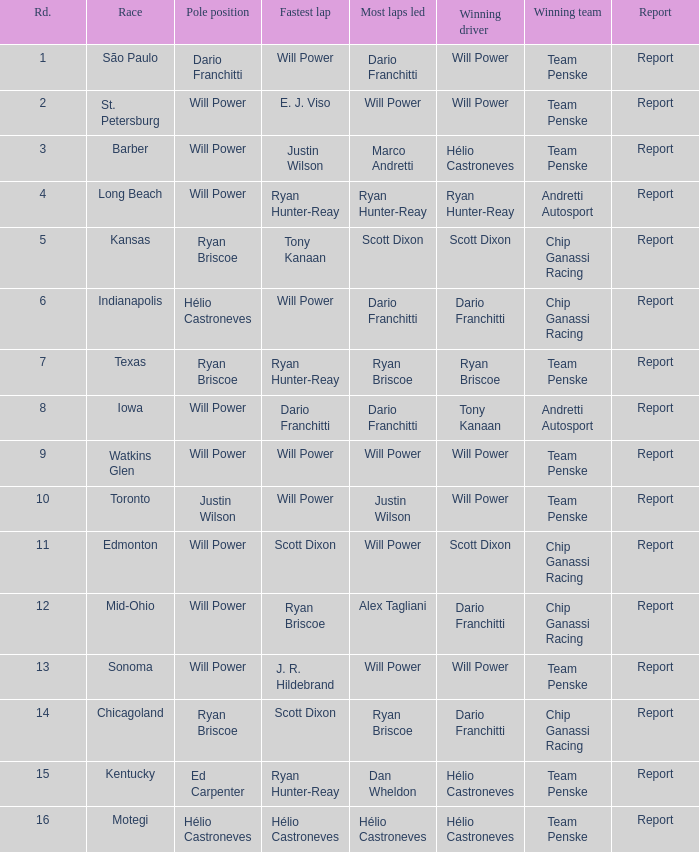What was the finishing position of the successful driver at chicagoland? 1.0. 